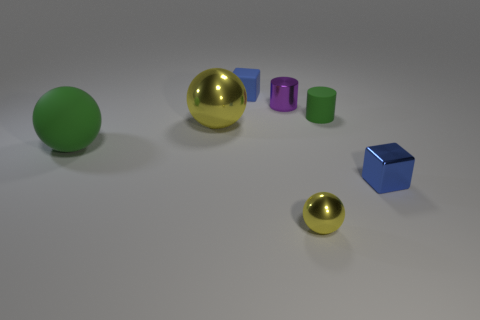What is the lighting like where these objects are placed? The lighting in this scene is diffuse, with soft shadows indicating an overhead light source, possibly in an enclosed space. This type of lighting reduces harsh shadows and evenly illuminates the objects, which highlights their colors and shapes without creating intense reflections or dark areas. 